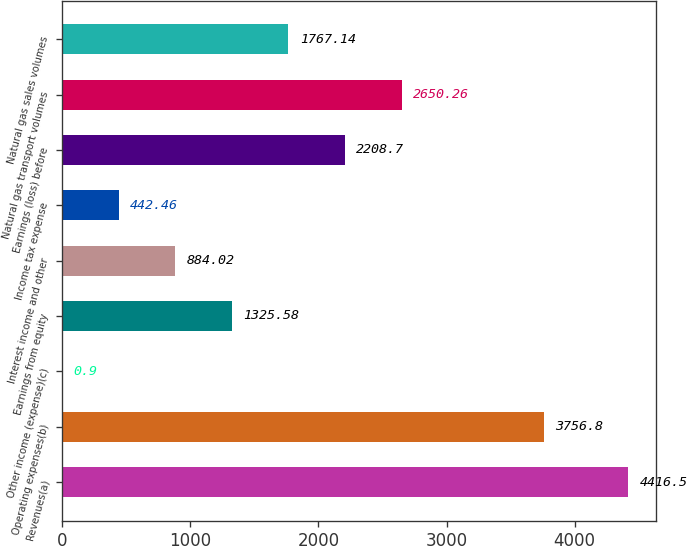Convert chart. <chart><loc_0><loc_0><loc_500><loc_500><bar_chart><fcel>Revenues(a)<fcel>Operating expenses(b)<fcel>Other income (expense)(c)<fcel>Earnings from equity<fcel>Interest income and other<fcel>Income tax expense<fcel>Earnings (loss) before<fcel>Natural gas transport volumes<fcel>Natural gas sales volumes<nl><fcel>4416.5<fcel>3756.8<fcel>0.9<fcel>1325.58<fcel>884.02<fcel>442.46<fcel>2208.7<fcel>2650.26<fcel>1767.14<nl></chart> 